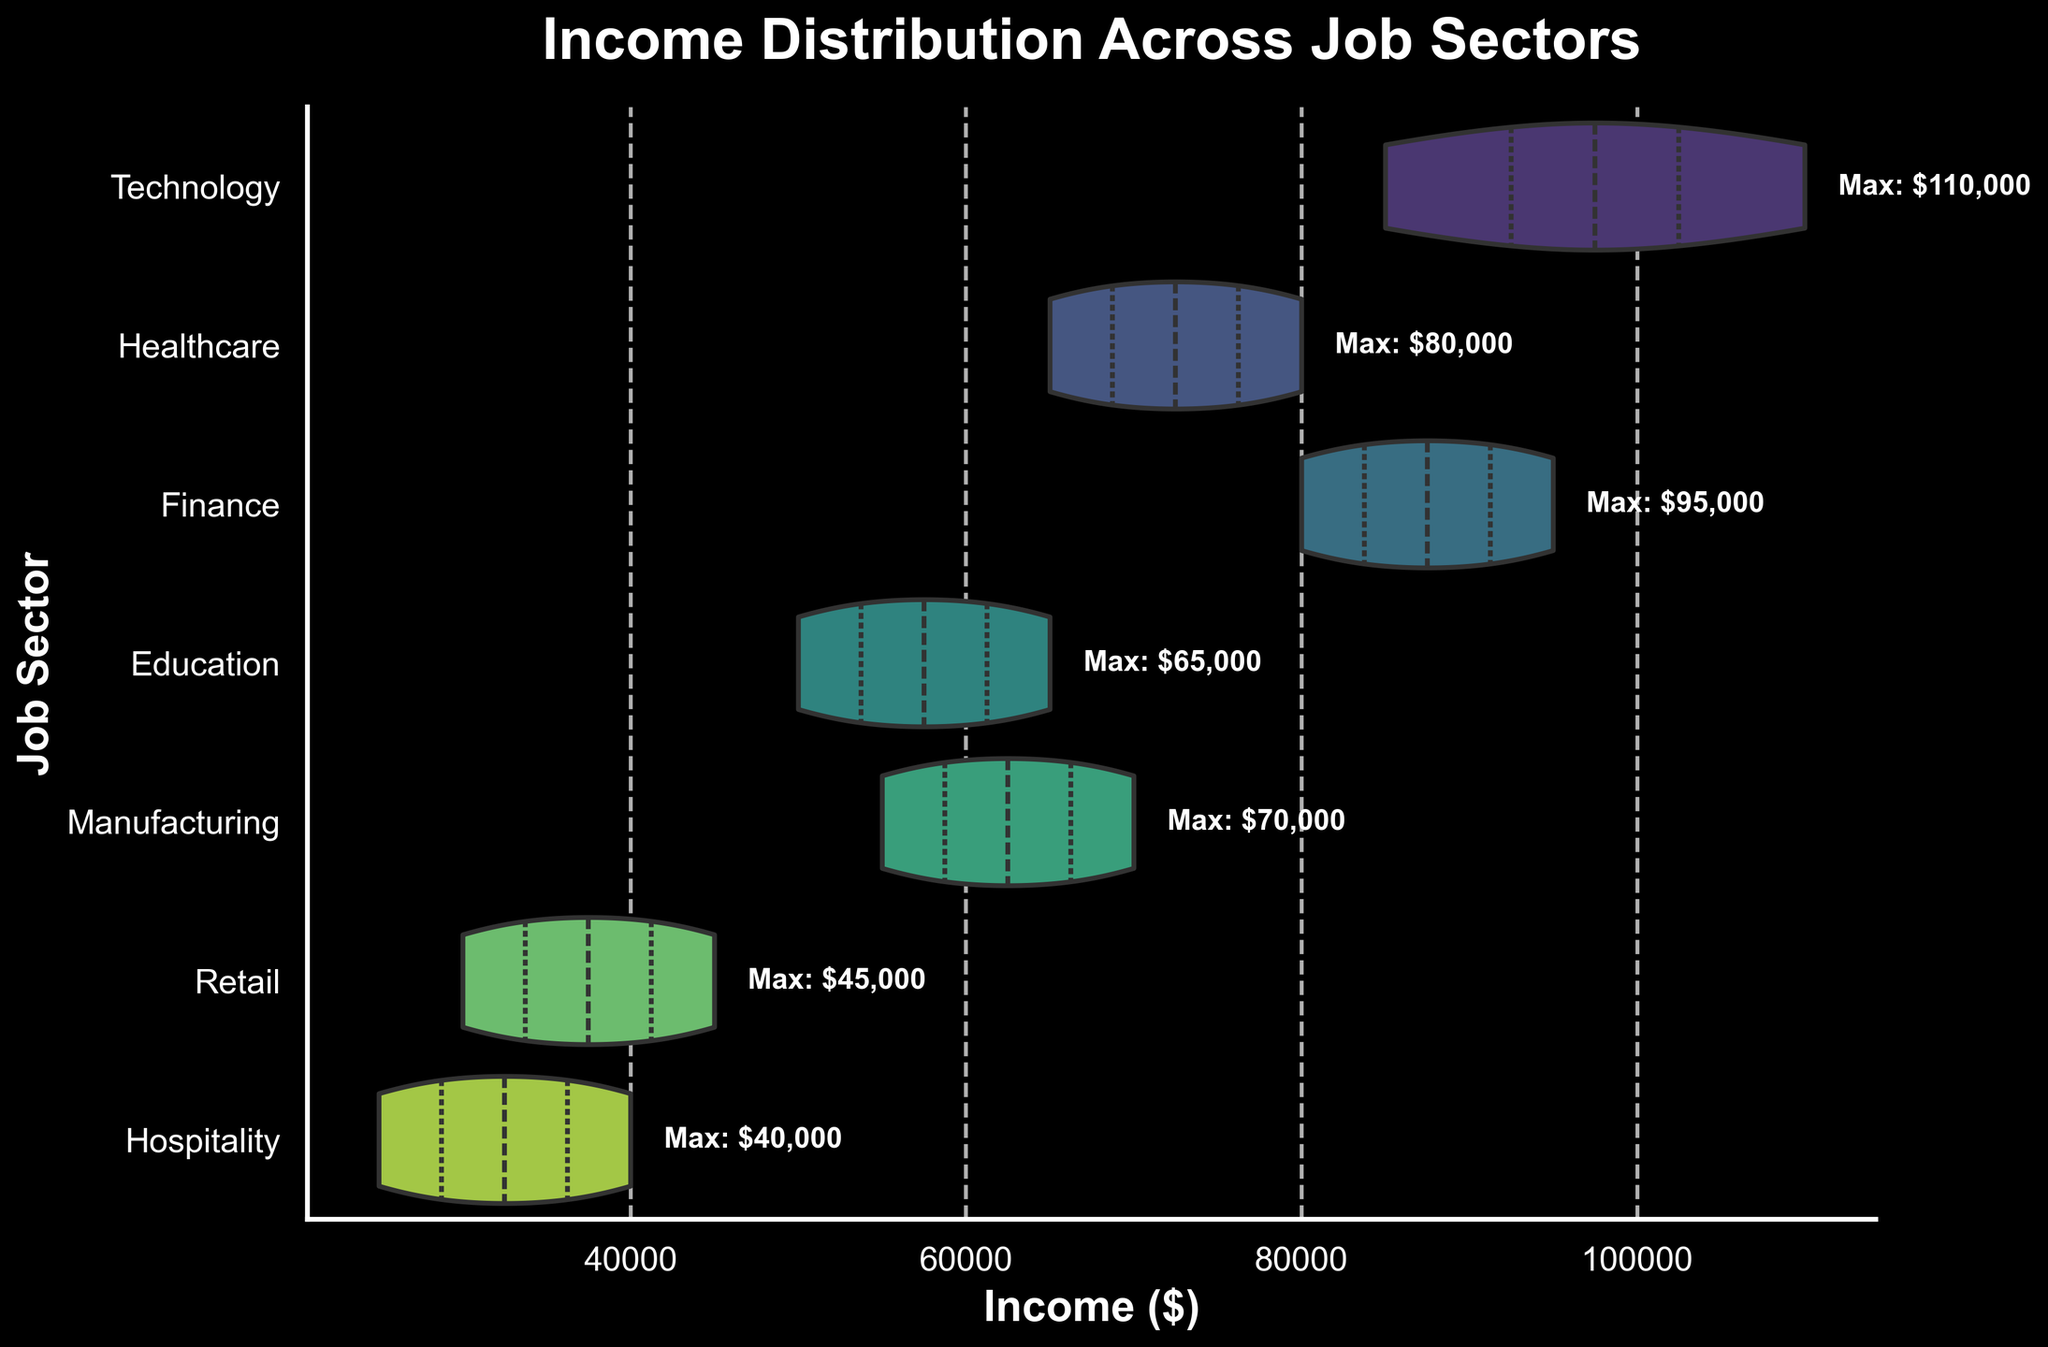What is the title of the figure? The title is prominently shown at the top of the figure.
Answer: Income Distribution Across Job Sectors How many job sectors are displayed in the violin plot? By counting the unique categories along the y-axis, we can determine the number of job sectors shown.
Answer: 7 What is the maximum income for the Finance sector? The figure includes text annotations for the maximum income values, and for the Finance sector, this value is indicated.
Answer: $95,000 Which job sector has the lowest range of income distribution? By comparing the width of the violins, we can see that the Hospitality sector has the narrowest violin, indicating the smallest range.
Answer: Hospitality What is the median income for the Healthcare sector? The inner quartile lines in the violin plots indicate the median. For the Healthcare sector, this line is midway along the width.
Answer: $75,000 Which job sector has the highest maximum income? By looking at the textual annotations for maximums, we can compare the values and see that the Technology sector has the highest value.
Answer: Technology How does the income distribution of the Retail sector compare to the Education sector? The violins for both sectors show that Retail has a lower overall income range compared to Education, evident from their positions on the x-axis.
Answer: Retail is lower Does any job sector have an income distribution above $100,000? We can observe that the Technology sector has part of its violin spread beyond the $100,000 mark.
Answer: Yes Which job sectors have an overlapping income range? By comparing the positions and widths of the violins, we see overlapping ranges between sectors such as Manufacturing and Education, and Finance and Healthcare.
Answer: Manufacturing and Education, Finance and Healthcare Is there any sector where the range of incomes appears to be evenly distributed? Equal width along the length of the violin plot implies even distribution. For the Education sector, the width is quite uniform.
Answer: Education 